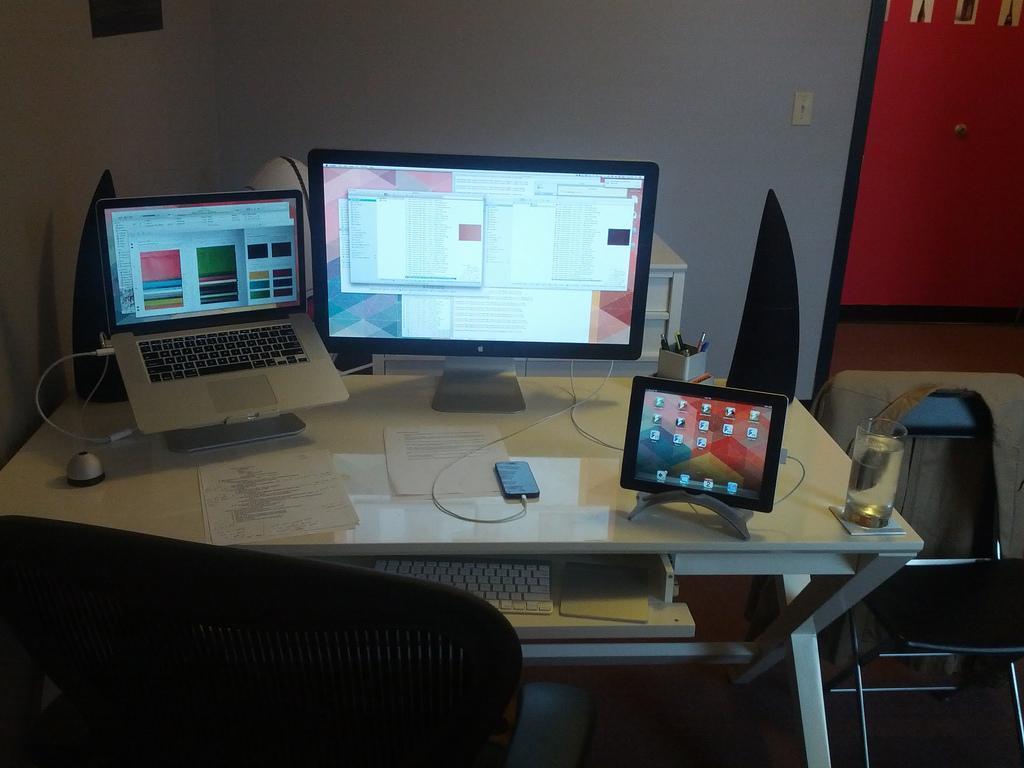How many computers are there?
Give a very brief answer. 2. 